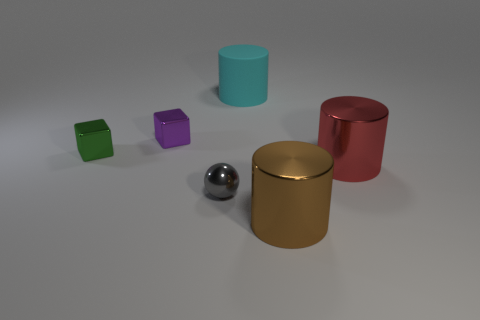Is there anything else that has the same material as the cyan cylinder?
Provide a succinct answer. No. Is the number of large red metal things that are left of the small green cube greater than the number of brown cylinders that are behind the brown metal cylinder?
Make the answer very short. No. Are the cyan cylinder and the purple object made of the same material?
Your answer should be compact. No. There is a object that is both right of the small sphere and left of the big brown cylinder; what is its shape?
Provide a succinct answer. Cylinder. The big brown object that is made of the same material as the red thing is what shape?
Ensure brevity in your answer.  Cylinder. Are there any big purple metal things?
Your response must be concise. No. Are there any small gray objects that are behind the gray ball that is to the left of the red thing?
Provide a short and direct response. No. What is the material of the tiny purple object that is the same shape as the green shiny thing?
Your answer should be very brief. Metal. Are there more large cyan things than tiny brown shiny cylinders?
Offer a terse response. Yes. Do the ball and the cylinder behind the green shiny thing have the same color?
Give a very brief answer. No. 